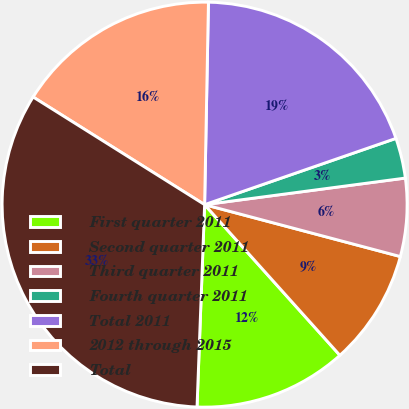<chart> <loc_0><loc_0><loc_500><loc_500><pie_chart><fcel>First quarter 2011<fcel>Second quarter 2011<fcel>Third quarter 2011<fcel>Fourth quarter 2011<fcel>Total 2011<fcel>2012 through 2015<fcel>Total<nl><fcel>12.24%<fcel>9.23%<fcel>6.22%<fcel>3.21%<fcel>19.39%<fcel>16.38%<fcel>33.32%<nl></chart> 